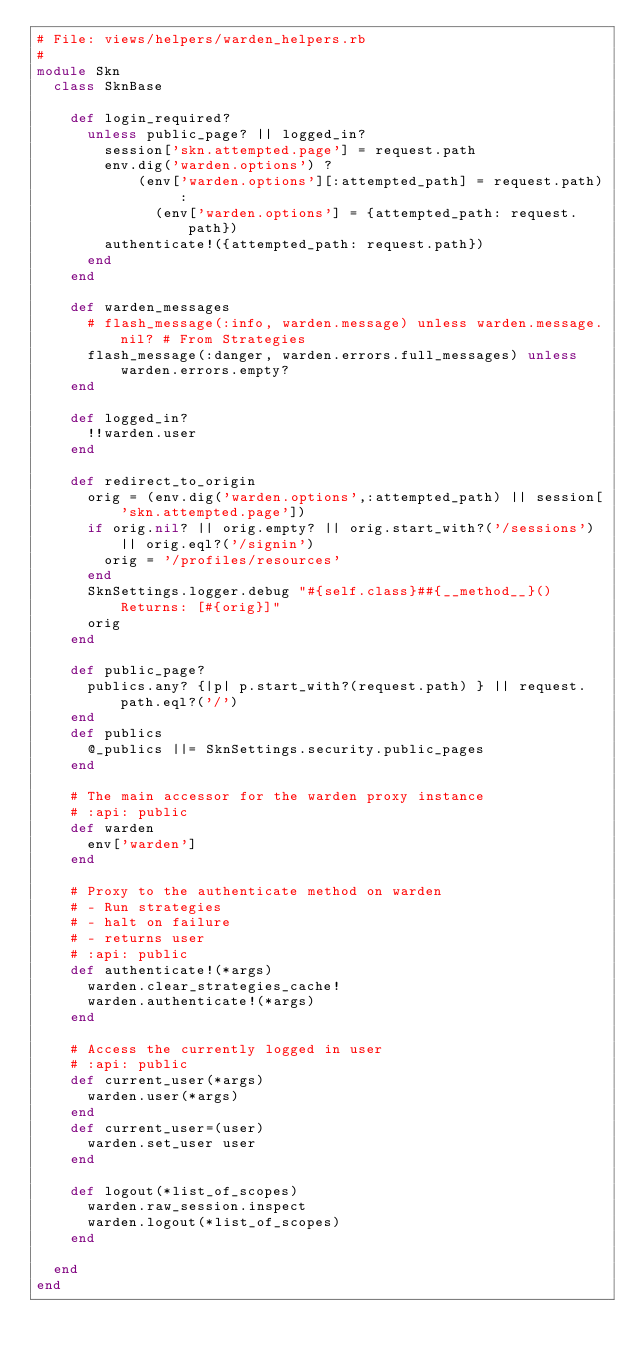<code> <loc_0><loc_0><loc_500><loc_500><_Ruby_># File: views/helpers/warden_helpers.rb
#
module Skn
  class SknBase

    def login_required?
      unless public_page? || logged_in?
        session['skn.attempted.page'] = request.path
        env.dig('warden.options') ?
            (env['warden.options'][:attempted_path] = request.path) :
              (env['warden.options'] = {attempted_path: request.path})
        authenticate!({attempted_path: request.path})
      end
    end

    def warden_messages
      # flash_message(:info, warden.message) unless warden.message.nil? # From Strategies
      flash_message(:danger, warden.errors.full_messages) unless warden.errors.empty?
    end

    def logged_in?
      !!warden.user
    end

    def redirect_to_origin
      orig = (env.dig('warden.options',:attempted_path) || session['skn.attempted.page'])
      if orig.nil? || orig.empty? || orig.start_with?('/sessions') || orig.eql?('/signin')
        orig = '/profiles/resources'
      end
      SknSettings.logger.debug "#{self.class}##{__method__}() Returns: [#{orig}]"
      orig
    end

    def public_page?
      publics.any? {|p| p.start_with?(request.path) } || request.path.eql?('/')
    end
    def publics
      @_publics ||= SknSettings.security.public_pages
    end

    # The main accessor for the warden proxy instance
    # :api: public
    def warden
      env['warden']
    end

    # Proxy to the authenticate method on warden
    # - Run strategies
    # - halt on failure
    # - returns user
    # :api: public
    def authenticate!(*args)
      warden.clear_strategies_cache!
      warden.authenticate!(*args)
    end

    # Access the currently logged in user
    # :api: public
    def current_user(*args)
      warden.user(*args)
    end
    def current_user=(user)
      warden.set_user user
    end

    def logout(*list_of_scopes)
      warden.raw_session.inspect
      warden.logout(*list_of_scopes)
    end

  end
end</code> 